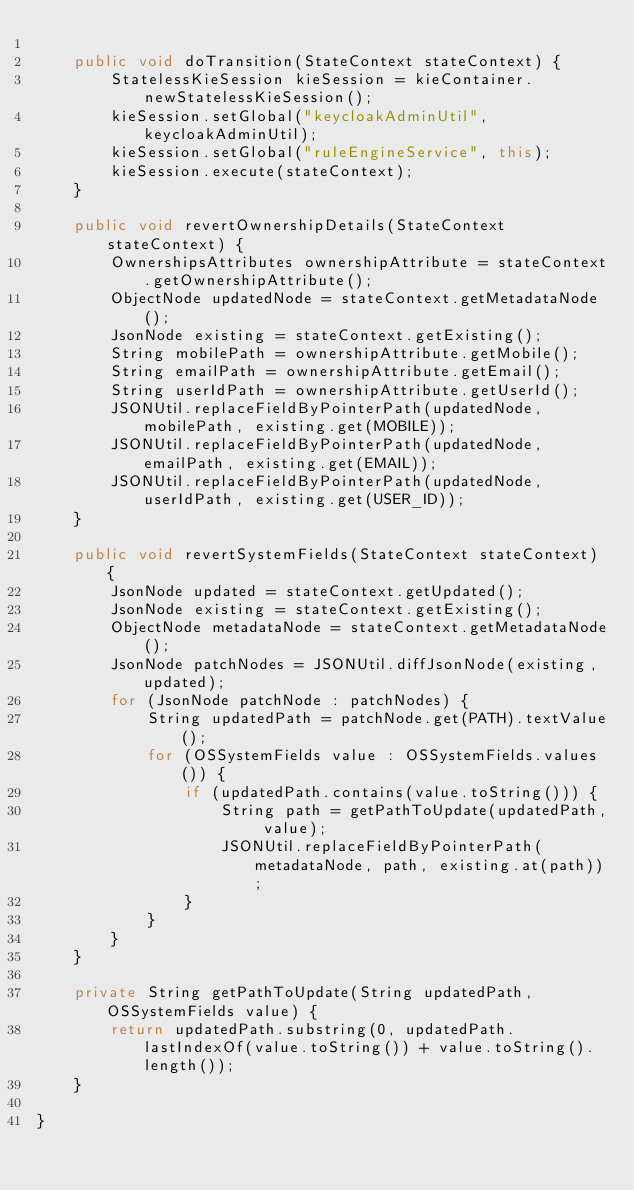Convert code to text. <code><loc_0><loc_0><loc_500><loc_500><_Java_>
    public void doTransition(StateContext stateContext) {
        StatelessKieSession kieSession = kieContainer.newStatelessKieSession();
        kieSession.setGlobal("keycloakAdminUtil", keycloakAdminUtil);
        kieSession.setGlobal("ruleEngineService", this);
        kieSession.execute(stateContext);
    }

    public void revertOwnershipDetails(StateContext stateContext) {
        OwnershipsAttributes ownershipAttribute = stateContext.getOwnershipAttribute();
        ObjectNode updatedNode = stateContext.getMetadataNode();
        JsonNode existing = stateContext.getExisting();
        String mobilePath = ownershipAttribute.getMobile();
        String emailPath = ownershipAttribute.getEmail();
        String userIdPath = ownershipAttribute.getUserId();
        JSONUtil.replaceFieldByPointerPath(updatedNode, mobilePath, existing.get(MOBILE));
        JSONUtil.replaceFieldByPointerPath(updatedNode, emailPath, existing.get(EMAIL));
        JSONUtil.replaceFieldByPointerPath(updatedNode, userIdPath, existing.get(USER_ID));
    }

    public void revertSystemFields(StateContext stateContext) {
        JsonNode updated = stateContext.getUpdated();
        JsonNode existing = stateContext.getExisting();
        ObjectNode metadataNode = stateContext.getMetadataNode();
        JsonNode patchNodes = JSONUtil.diffJsonNode(existing, updated);
        for (JsonNode patchNode : patchNodes) {
            String updatedPath = patchNode.get(PATH).textValue();
            for (OSSystemFields value : OSSystemFields.values()) {
                if (updatedPath.contains(value.toString())) {
                    String path = getPathToUpdate(updatedPath, value);
                    JSONUtil.replaceFieldByPointerPath(metadataNode, path, existing.at(path));
                }
            }
        }
    }

    private String getPathToUpdate(String updatedPath, OSSystemFields value) {
        return updatedPath.substring(0, updatedPath.lastIndexOf(value.toString()) + value.toString().length());
    }

}
</code> 